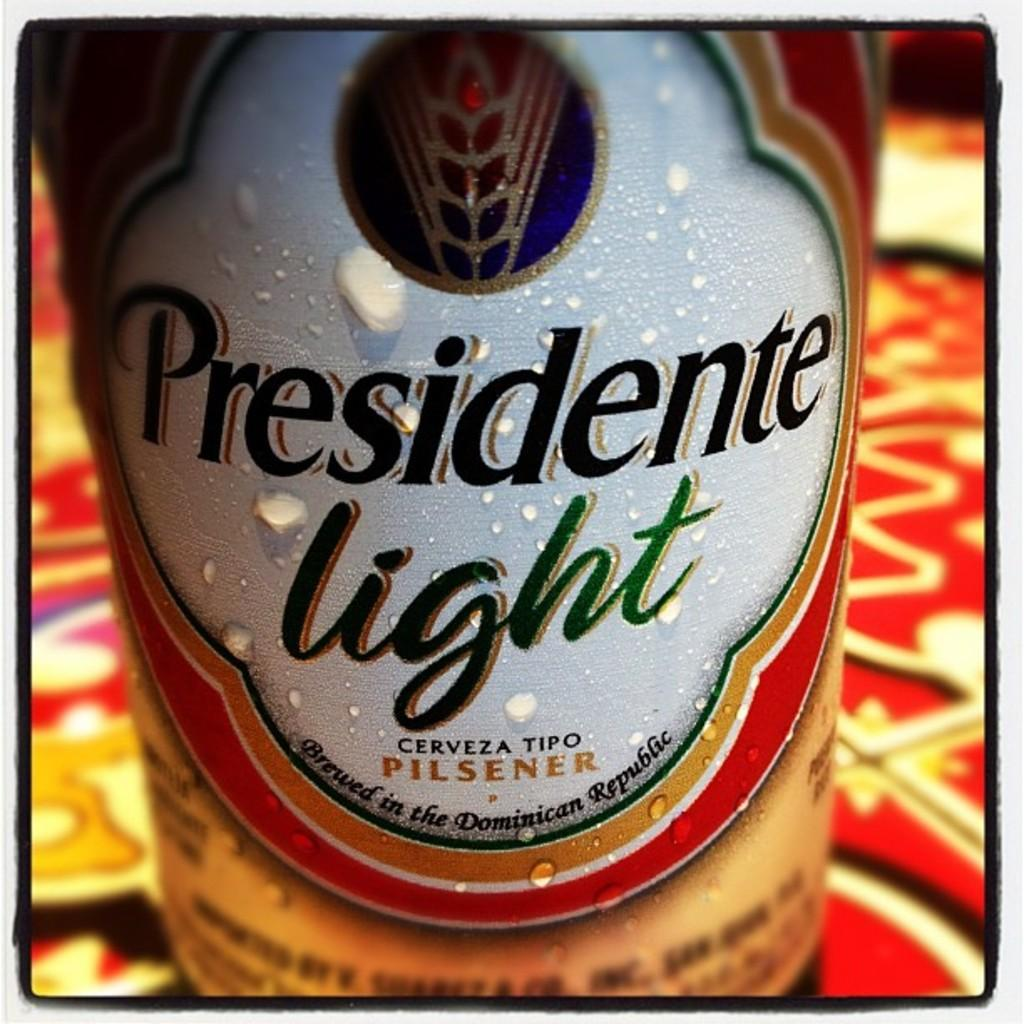Provide a one-sentence caption for the provided image. Droplets of moisture dot a Presidente light Pilsner label. 